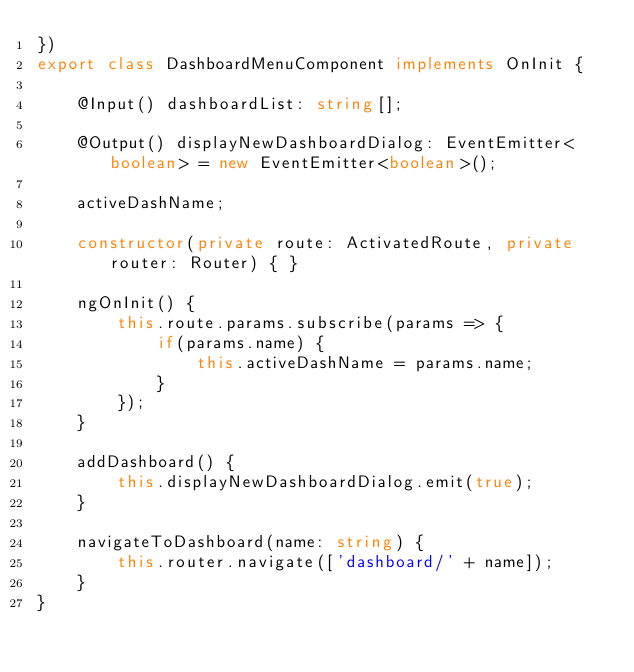<code> <loc_0><loc_0><loc_500><loc_500><_TypeScript_>})
export class DashboardMenuComponent implements OnInit {

    @Input() dashboardList: string[];

    @Output() displayNewDashboardDialog: EventEmitter<boolean> = new EventEmitter<boolean>();

    activeDashName;

    constructor(private route: ActivatedRoute, private router: Router) { }

    ngOnInit() {
        this.route.params.subscribe(params => {
            if(params.name) {
                this.activeDashName = params.name;
            }
        });
    }

    addDashboard() {
        this.displayNewDashboardDialog.emit(true);
    }

    navigateToDashboard(name: string) {
        this.router.navigate(['dashboard/' + name]);
    }
}
</code> 